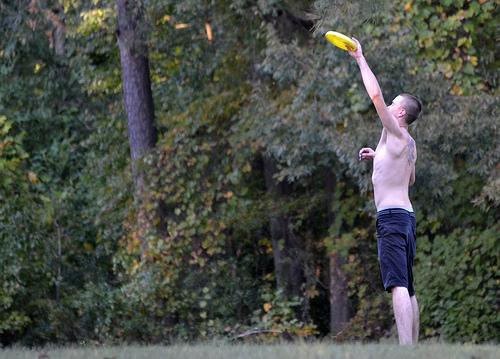What is the main activity the man in the image is engaged in? The man is playing frisbee. What is the color of the frisbee in the image? The frisbee is yellow. Determine the overall sentiment of the image. The image has a sentiment of playfulness and activity, with the man catching the frisbee outdoors. What distinguishes the tallest tree trunk in the image? The tallest tree trunk in the image is shown to have golden leaves on it. Identify the color and type of clothing worn by the man in the image. The man is wearing blue shorts and is shirtless. How is the man holding the frisbee? The man is holding the frisbee with his left hand. Explain the scene depicted through the image. A man is standing on dry grass and catching a yellow frisbee while wearing blue shorts; there are trees with leaves and tree trunks in the background. Describe any visible tattoos on the man in the image. There is a tattoo on the man's back, near his right shoulder. What type of greenery does the image show on the right side? There are green leaves on the right side of the photo. Count the number of large tree trunks in the image. There are three large tree trunks. 